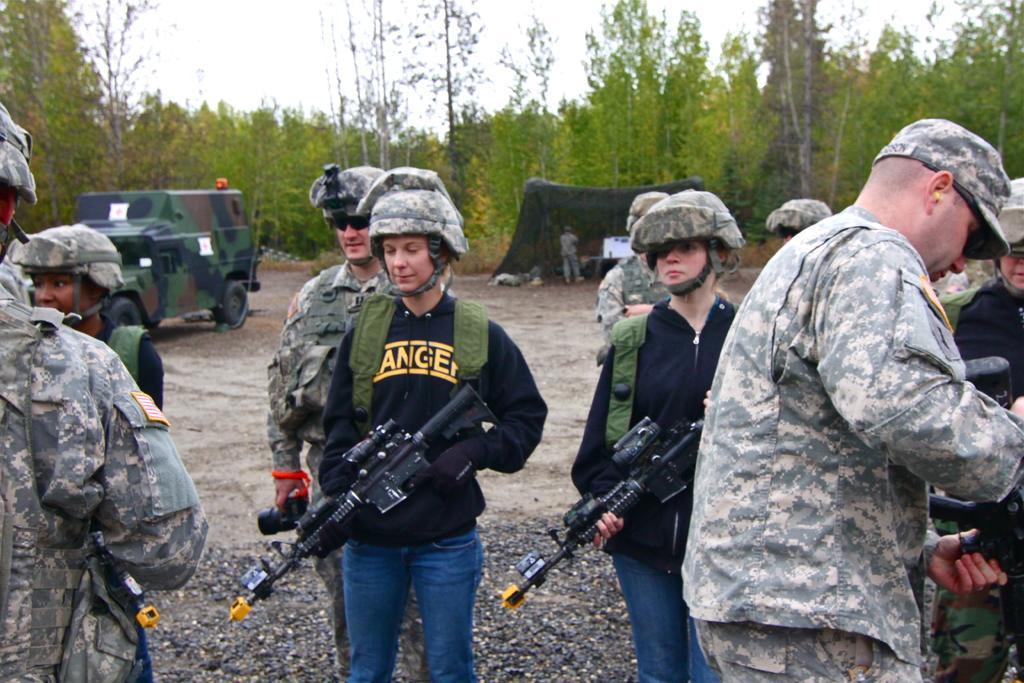Please provide a concise description of this image. In this image I can see group of people standing holding gun. The person in front wearing black shirt, blue jeans. Background I can see few vehicles, trees in green color and sky in white color. 